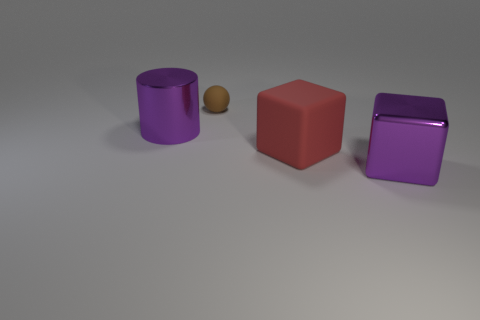Are there any other things that are the same material as the brown object?
Provide a succinct answer. Yes. There is another big thing that is the same shape as the red object; what is it made of?
Give a very brief answer. Metal. Are there an equal number of big purple metallic cylinders behind the rubber cube and red cubes?
Give a very brief answer. Yes. There is a thing that is both behind the large rubber object and to the right of the purple metal cylinder; what is its size?
Offer a very short reply. Small. Is there any other thing that has the same color as the small rubber ball?
Keep it short and to the point. No. There is a purple metal thing that is on the right side of the object behind the purple shiny cylinder; what is its size?
Offer a very short reply. Large. The big thing that is right of the tiny brown thing and behind the big purple cube is what color?
Give a very brief answer. Red. What number of other things are there of the same size as the brown matte sphere?
Ensure brevity in your answer.  0. There is a purple cylinder; is it the same size as the purple metallic object that is right of the ball?
Ensure brevity in your answer.  Yes. What color is the other cube that is the same size as the shiny block?
Provide a succinct answer. Red. 